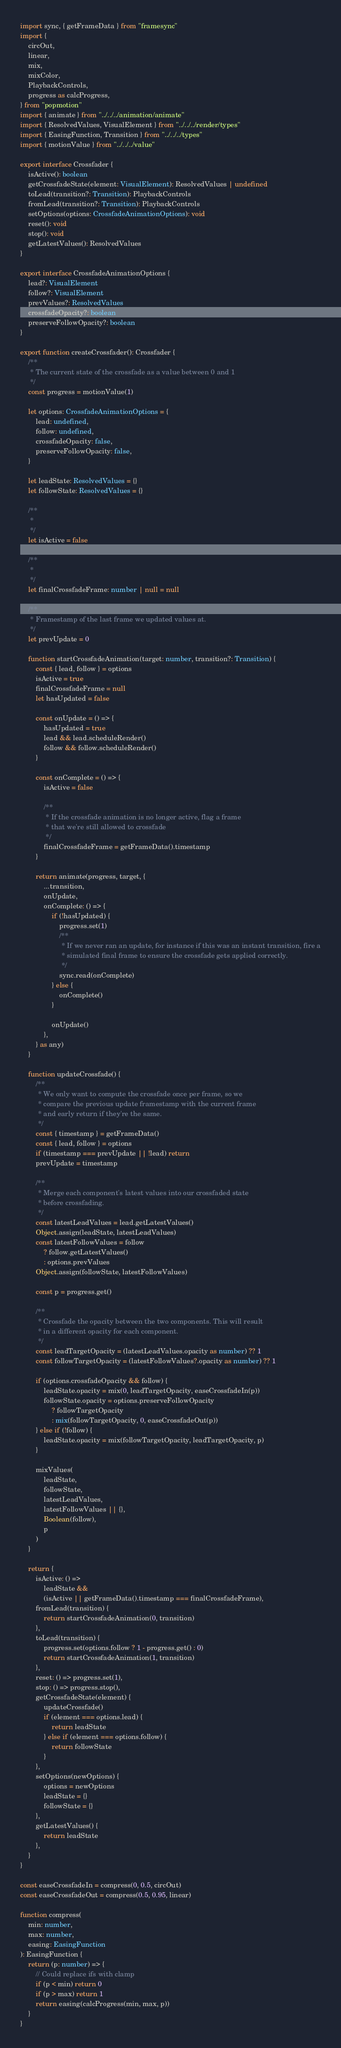<code> <loc_0><loc_0><loc_500><loc_500><_TypeScript_>import sync, { getFrameData } from "framesync"
import {
    circOut,
    linear,
    mix,
    mixColor,
    PlaybackControls,
    progress as calcProgress,
} from "popmotion"
import { animate } from "../../../animation/animate"
import { ResolvedValues, VisualElement } from "../../../render/types"
import { EasingFunction, Transition } from "../../../types"
import { motionValue } from "../../../value"

export interface Crossfader {
    isActive(): boolean
    getCrossfadeState(element: VisualElement): ResolvedValues | undefined
    toLead(transition?: Transition): PlaybackControls
    fromLead(transition?: Transition): PlaybackControls
    setOptions(options: CrossfadeAnimationOptions): void
    reset(): void
    stop(): void
    getLatestValues(): ResolvedValues
}

export interface CrossfadeAnimationOptions {
    lead?: VisualElement
    follow?: VisualElement
    prevValues?: ResolvedValues
    crossfadeOpacity?: boolean
    preserveFollowOpacity?: boolean
}

export function createCrossfader(): Crossfader {
    /**
     * The current state of the crossfade as a value between 0 and 1
     */
    const progress = motionValue(1)

    let options: CrossfadeAnimationOptions = {
        lead: undefined,
        follow: undefined,
        crossfadeOpacity: false,
        preserveFollowOpacity: false,
    }

    let leadState: ResolvedValues = {}
    let followState: ResolvedValues = {}

    /**
     *
     */
    let isActive = false

    /**
     *
     */
    let finalCrossfadeFrame: number | null = null

    /**
     * Framestamp of the last frame we updated values at.
     */
    let prevUpdate = 0

    function startCrossfadeAnimation(target: number, transition?: Transition) {
        const { lead, follow } = options
        isActive = true
        finalCrossfadeFrame = null
        let hasUpdated = false

        const onUpdate = () => {
            hasUpdated = true
            lead && lead.scheduleRender()
            follow && follow.scheduleRender()
        }

        const onComplete = () => {
            isActive = false

            /**
             * If the crossfade animation is no longer active, flag a frame
             * that we're still allowed to crossfade
             */
            finalCrossfadeFrame = getFrameData().timestamp
        }

        return animate(progress, target, {
            ...transition,
            onUpdate,
            onComplete: () => {
                if (!hasUpdated) {
                    progress.set(1)
                    /**
                     * If we never ran an update, for instance if this was an instant transition, fire a
                     * simulated final frame to ensure the crossfade gets applied correctly.
                     */
                    sync.read(onComplete)
                } else {
                    onComplete()
                }

                onUpdate()
            },
        } as any)
    }

    function updateCrossfade() {
        /**
         * We only want to compute the crossfade once per frame, so we
         * compare the previous update framestamp with the current frame
         * and early return if they're the same.
         */
        const { timestamp } = getFrameData()
        const { lead, follow } = options
        if (timestamp === prevUpdate || !lead) return
        prevUpdate = timestamp

        /**
         * Merge each component's latest values into our crossfaded state
         * before crossfading.
         */
        const latestLeadValues = lead.getLatestValues()
        Object.assign(leadState, latestLeadValues)
        const latestFollowValues = follow
            ? follow.getLatestValues()
            : options.prevValues
        Object.assign(followState, latestFollowValues)

        const p = progress.get()

        /**
         * Crossfade the opacity between the two components. This will result
         * in a different opacity for each component.
         */
        const leadTargetOpacity = (latestLeadValues.opacity as number) ?? 1
        const followTargetOpacity = (latestFollowValues?.opacity as number) ?? 1

        if (options.crossfadeOpacity && follow) {
            leadState.opacity = mix(0, leadTargetOpacity, easeCrossfadeIn(p))
            followState.opacity = options.preserveFollowOpacity
                ? followTargetOpacity
                : mix(followTargetOpacity, 0, easeCrossfadeOut(p))
        } else if (!follow) {
            leadState.opacity = mix(followTargetOpacity, leadTargetOpacity, p)
        }

        mixValues(
            leadState,
            followState,
            latestLeadValues,
            latestFollowValues || {},
            Boolean(follow),
            p
        )
    }

    return {
        isActive: () =>
            leadState &&
            (isActive || getFrameData().timestamp === finalCrossfadeFrame),
        fromLead(transition) {
            return startCrossfadeAnimation(0, transition)
        },
        toLead(transition) {
            progress.set(options.follow ? 1 - progress.get() : 0)
            return startCrossfadeAnimation(1, transition)
        },
        reset: () => progress.set(1),
        stop: () => progress.stop(),
        getCrossfadeState(element) {
            updateCrossfade()
            if (element === options.lead) {
                return leadState
            } else if (element === options.follow) {
                return followState
            }
        },
        setOptions(newOptions) {
            options = newOptions
            leadState = {}
            followState = {}
        },
        getLatestValues() {
            return leadState
        },
    }
}

const easeCrossfadeIn = compress(0, 0.5, circOut)
const easeCrossfadeOut = compress(0.5, 0.95, linear)

function compress(
    min: number,
    max: number,
    easing: EasingFunction
): EasingFunction {
    return (p: number) => {
        // Could replace ifs with clamp
        if (p < min) return 0
        if (p > max) return 1
        return easing(calcProgress(min, max, p))
    }
}
</code> 